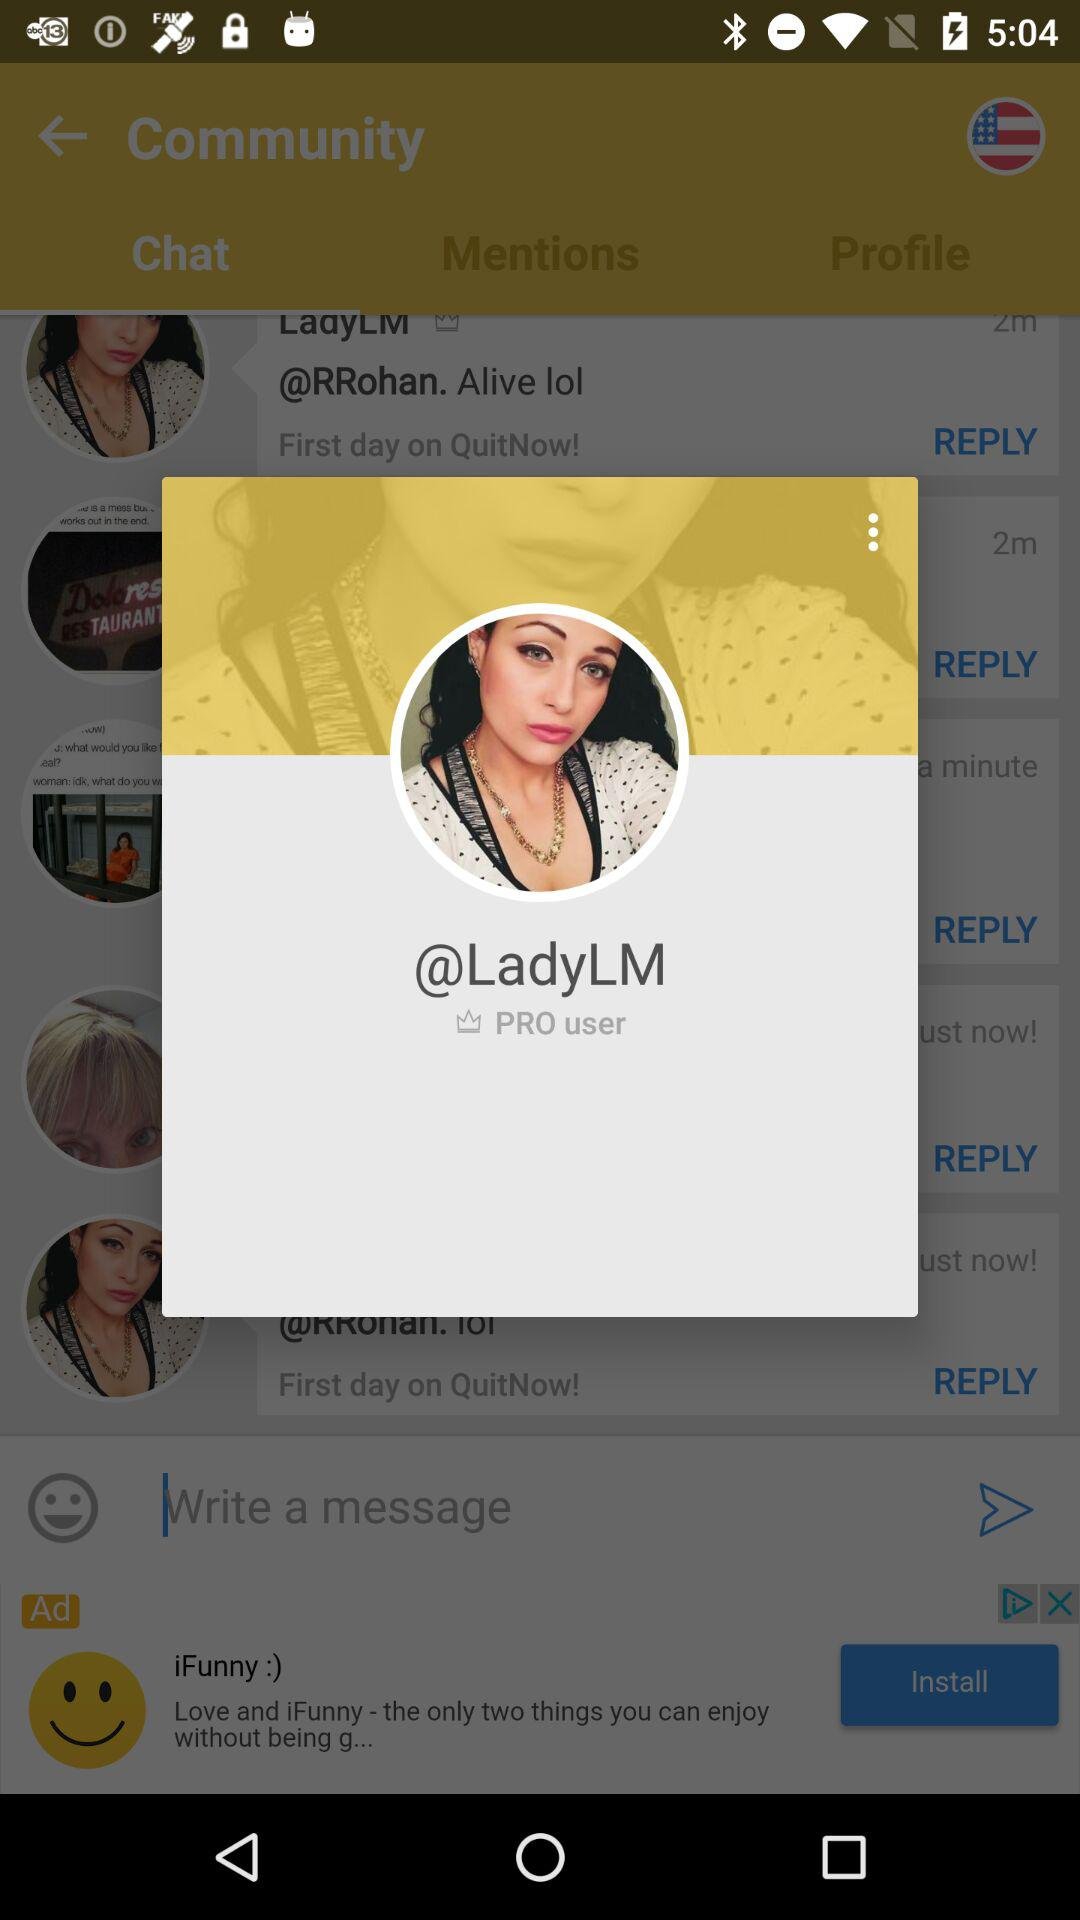How old is "LadyLM"?
When the provided information is insufficient, respond with <no answer>. <no answer> 